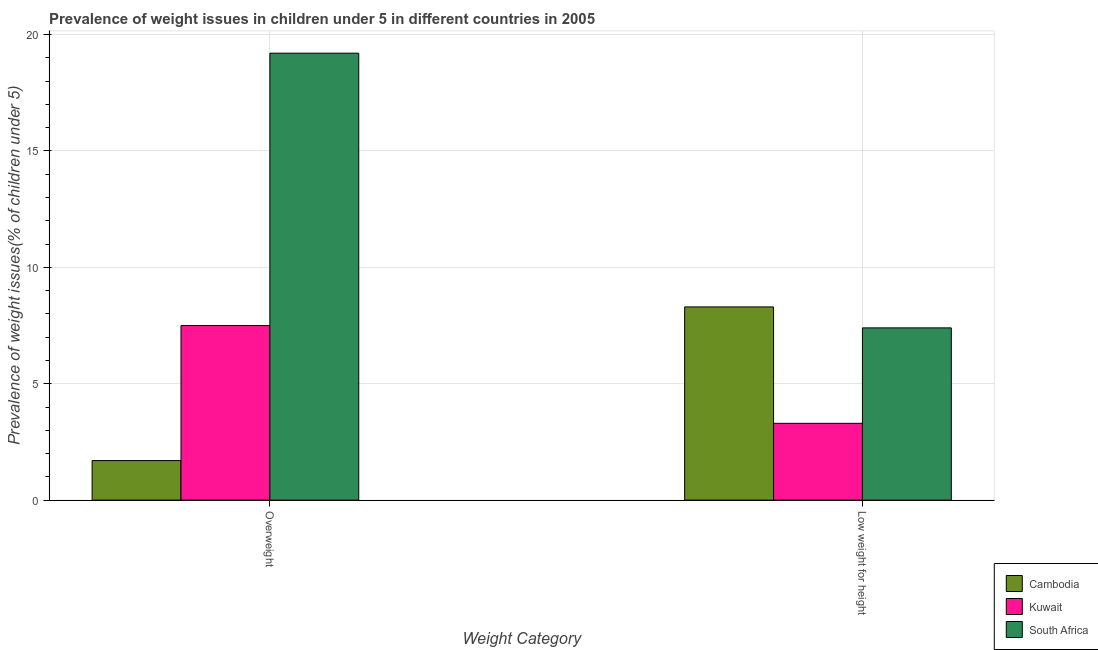How many groups of bars are there?
Provide a short and direct response. 2. Are the number of bars per tick equal to the number of legend labels?
Your answer should be compact. Yes. How many bars are there on the 2nd tick from the left?
Keep it short and to the point. 3. How many bars are there on the 1st tick from the right?
Provide a short and direct response. 3. What is the label of the 1st group of bars from the left?
Your response must be concise. Overweight. What is the percentage of underweight children in Kuwait?
Give a very brief answer. 3.3. Across all countries, what is the maximum percentage of underweight children?
Provide a short and direct response. 8.3. Across all countries, what is the minimum percentage of underweight children?
Make the answer very short. 3.3. In which country was the percentage of underweight children maximum?
Your answer should be very brief. Cambodia. In which country was the percentage of overweight children minimum?
Give a very brief answer. Cambodia. What is the total percentage of underweight children in the graph?
Keep it short and to the point. 19. What is the difference between the percentage of underweight children in Kuwait and that in Cambodia?
Your answer should be very brief. -5. What is the difference between the percentage of overweight children in Cambodia and the percentage of underweight children in Kuwait?
Keep it short and to the point. -1.6. What is the average percentage of underweight children per country?
Make the answer very short. 6.33. What is the difference between the percentage of underweight children and percentage of overweight children in Cambodia?
Ensure brevity in your answer.  6.6. In how many countries, is the percentage of overweight children greater than 1 %?
Provide a succinct answer. 3. What is the ratio of the percentage of underweight children in Cambodia to that in Kuwait?
Your answer should be very brief. 2.52. Is the percentage of underweight children in Kuwait less than that in South Africa?
Make the answer very short. Yes. In how many countries, is the percentage of underweight children greater than the average percentage of underweight children taken over all countries?
Offer a terse response. 2. What does the 1st bar from the left in Low weight for height represents?
Provide a succinct answer. Cambodia. What does the 2nd bar from the right in Low weight for height represents?
Ensure brevity in your answer.  Kuwait. How many bars are there?
Your response must be concise. 6. Are all the bars in the graph horizontal?
Your answer should be very brief. No. Are the values on the major ticks of Y-axis written in scientific E-notation?
Provide a succinct answer. No. Does the graph contain grids?
Provide a succinct answer. Yes. How are the legend labels stacked?
Provide a succinct answer. Vertical. What is the title of the graph?
Provide a succinct answer. Prevalence of weight issues in children under 5 in different countries in 2005. What is the label or title of the X-axis?
Give a very brief answer. Weight Category. What is the label or title of the Y-axis?
Provide a succinct answer. Prevalence of weight issues(% of children under 5). What is the Prevalence of weight issues(% of children under 5) of Cambodia in Overweight?
Provide a short and direct response. 1.7. What is the Prevalence of weight issues(% of children under 5) in South Africa in Overweight?
Offer a very short reply. 19.2. What is the Prevalence of weight issues(% of children under 5) of Cambodia in Low weight for height?
Your response must be concise. 8.3. What is the Prevalence of weight issues(% of children under 5) of Kuwait in Low weight for height?
Offer a very short reply. 3.3. What is the Prevalence of weight issues(% of children under 5) of South Africa in Low weight for height?
Provide a short and direct response. 7.4. Across all Weight Category, what is the maximum Prevalence of weight issues(% of children under 5) of Cambodia?
Your answer should be very brief. 8.3. Across all Weight Category, what is the maximum Prevalence of weight issues(% of children under 5) of South Africa?
Provide a short and direct response. 19.2. Across all Weight Category, what is the minimum Prevalence of weight issues(% of children under 5) in Cambodia?
Your answer should be compact. 1.7. Across all Weight Category, what is the minimum Prevalence of weight issues(% of children under 5) in Kuwait?
Provide a succinct answer. 3.3. Across all Weight Category, what is the minimum Prevalence of weight issues(% of children under 5) of South Africa?
Offer a terse response. 7.4. What is the total Prevalence of weight issues(% of children under 5) of Kuwait in the graph?
Keep it short and to the point. 10.8. What is the total Prevalence of weight issues(% of children under 5) of South Africa in the graph?
Your answer should be compact. 26.6. What is the difference between the Prevalence of weight issues(% of children under 5) in Cambodia in Overweight and that in Low weight for height?
Give a very brief answer. -6.6. What is the difference between the Prevalence of weight issues(% of children under 5) in Kuwait in Overweight and that in Low weight for height?
Give a very brief answer. 4.2. What is the difference between the Prevalence of weight issues(% of children under 5) in South Africa in Overweight and that in Low weight for height?
Provide a short and direct response. 11.8. What is the difference between the Prevalence of weight issues(% of children under 5) in Cambodia in Overweight and the Prevalence of weight issues(% of children under 5) in Kuwait in Low weight for height?
Your response must be concise. -1.6. What is the difference between the Prevalence of weight issues(% of children under 5) in Cambodia in Overweight and the Prevalence of weight issues(% of children under 5) in South Africa in Low weight for height?
Provide a short and direct response. -5.7. What is the average Prevalence of weight issues(% of children under 5) of Kuwait per Weight Category?
Provide a short and direct response. 5.4. What is the average Prevalence of weight issues(% of children under 5) of South Africa per Weight Category?
Your answer should be compact. 13.3. What is the difference between the Prevalence of weight issues(% of children under 5) in Cambodia and Prevalence of weight issues(% of children under 5) in Kuwait in Overweight?
Your answer should be compact. -5.8. What is the difference between the Prevalence of weight issues(% of children under 5) of Cambodia and Prevalence of weight issues(% of children under 5) of South Africa in Overweight?
Make the answer very short. -17.5. What is the difference between the Prevalence of weight issues(% of children under 5) in Kuwait and Prevalence of weight issues(% of children under 5) in South Africa in Overweight?
Keep it short and to the point. -11.7. What is the difference between the Prevalence of weight issues(% of children under 5) of Cambodia and Prevalence of weight issues(% of children under 5) of South Africa in Low weight for height?
Offer a very short reply. 0.9. What is the difference between the Prevalence of weight issues(% of children under 5) of Kuwait and Prevalence of weight issues(% of children under 5) of South Africa in Low weight for height?
Provide a succinct answer. -4.1. What is the ratio of the Prevalence of weight issues(% of children under 5) of Cambodia in Overweight to that in Low weight for height?
Your response must be concise. 0.2. What is the ratio of the Prevalence of weight issues(% of children under 5) of Kuwait in Overweight to that in Low weight for height?
Your response must be concise. 2.27. What is the ratio of the Prevalence of weight issues(% of children under 5) in South Africa in Overweight to that in Low weight for height?
Give a very brief answer. 2.59. What is the difference between the highest and the second highest Prevalence of weight issues(% of children under 5) in South Africa?
Provide a short and direct response. 11.8. What is the difference between the highest and the lowest Prevalence of weight issues(% of children under 5) in Kuwait?
Make the answer very short. 4.2. 